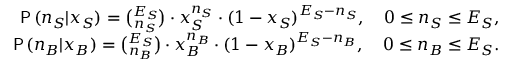<formula> <loc_0><loc_0><loc_500><loc_500>\begin{array} { r l r } & { P \, ( n _ { S } | x _ { S } ) = { \binom { E _ { S } } { n _ { S } } } \cdot x _ { S } ^ { n _ { S } } \cdot ( 1 - x _ { S } ) ^ { E _ { S } - n _ { S } } , \quad 0 \leq n _ { S } \leq E _ { S } , } \\ & { P \, ( n _ { B } | x _ { B } ) = { \binom { E _ { S } } { n _ { B } } } \cdot x _ { B } ^ { n _ { B } } \cdot ( 1 - x _ { B } ) ^ { E _ { S } - n _ { B } } , \quad 0 \leq n _ { B } \leq E _ { S } . } \end{array}</formula> 